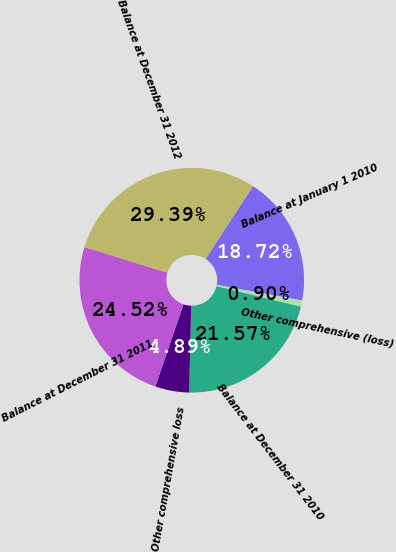Convert chart. <chart><loc_0><loc_0><loc_500><loc_500><pie_chart><fcel>Balance at January 1 2010<fcel>Other comprehensive (loss)<fcel>Balance at December 31 2010<fcel>Other comprehensive loss<fcel>Balance at December 31 2011<fcel>Balance at December 31 2012<nl><fcel>18.72%<fcel>0.9%<fcel>21.57%<fcel>4.89%<fcel>24.52%<fcel>29.39%<nl></chart> 